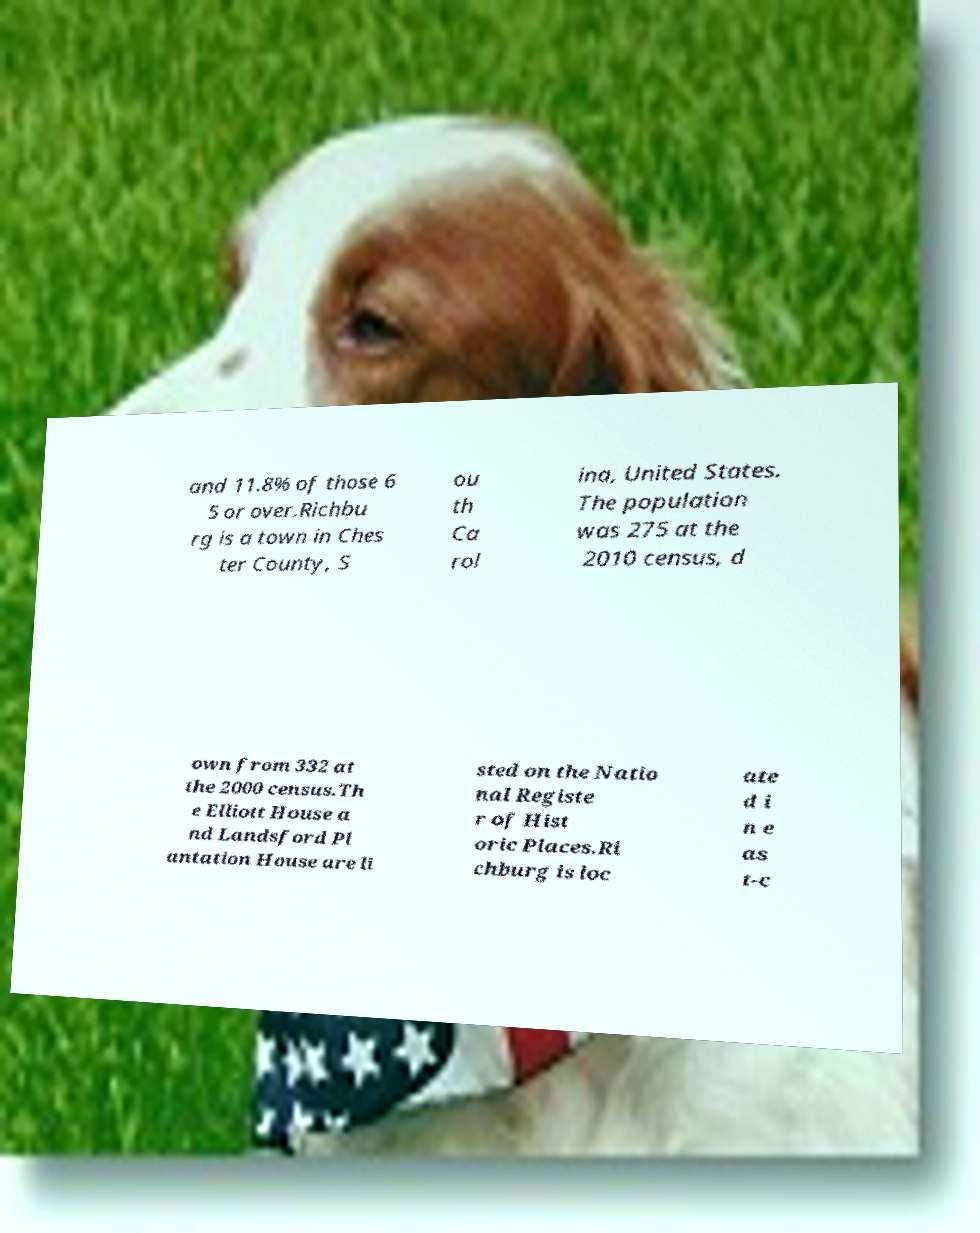Please read and relay the text visible in this image. What does it say? and 11.8% of those 6 5 or over.Richbu rg is a town in Ches ter County, S ou th Ca rol ina, United States. The population was 275 at the 2010 census, d own from 332 at the 2000 census.Th e Elliott House a nd Landsford Pl antation House are li sted on the Natio nal Registe r of Hist oric Places.Ri chburg is loc ate d i n e as t-c 